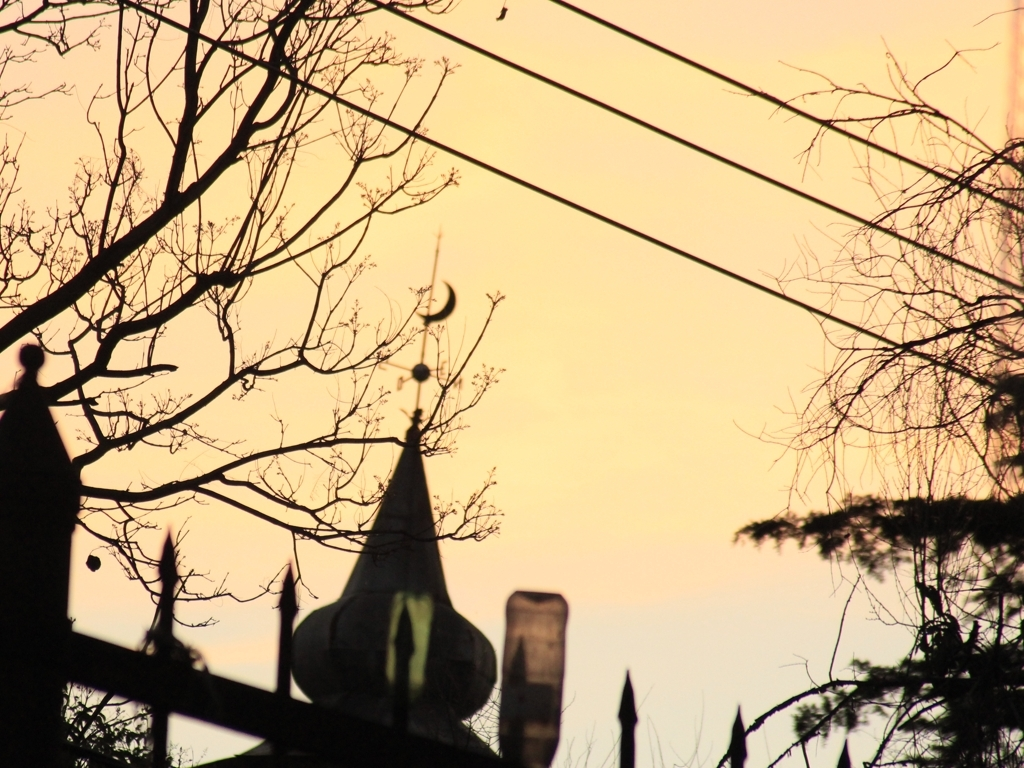How do the power lines in the image affect the composition and the viewer's experience? The power lines create an additional layer of complexity, drawing the attention away from the natural and architectural elements. They intersect the composition, reminding us of the intertwining of human infrastructure with the environment and can evoke a sense of intrusion or connection, depending on the viewer's interpretation. 